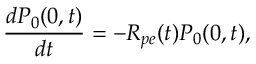<formula> <loc_0><loc_0><loc_500><loc_500>\frac { d P _ { 0 } ( 0 , t ) } { d t } = - R _ { p e } ( t ) P _ { 0 } ( 0 , t ) ,</formula> 